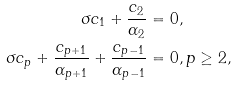<formula> <loc_0><loc_0><loc_500><loc_500>\sigma c _ { 1 } + \frac { c _ { 2 } } { \alpha _ { 2 } } & = 0 , \\ \sigma c _ { p } + \frac { c _ { p + 1 } } { \alpha _ { p + 1 } } + \frac { c _ { p - 1 } } { \alpha _ { p - 1 } } & = 0 , p \geq 2 ,</formula> 